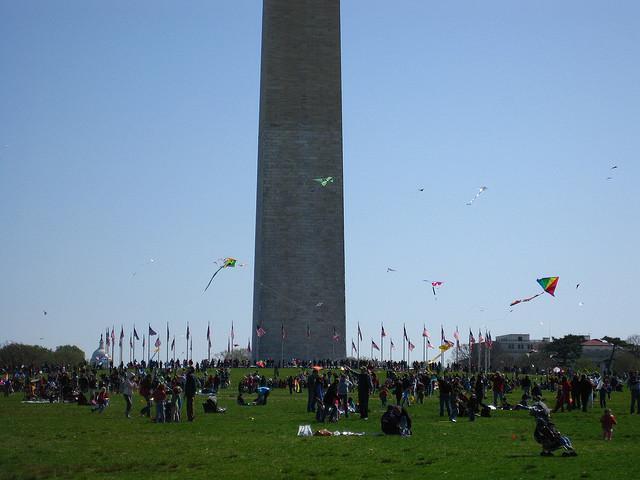How many cows are pictured?
Give a very brief answer. 0. 